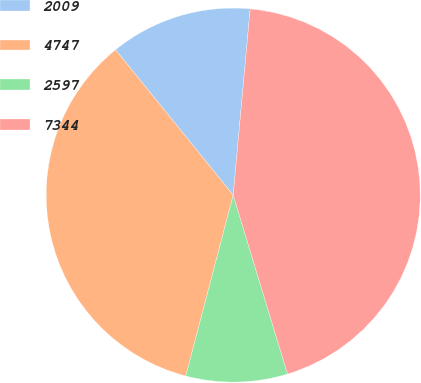Convert chart to OTSL. <chart><loc_0><loc_0><loc_500><loc_500><pie_chart><fcel>2009<fcel>4747<fcel>2597<fcel>7344<nl><fcel>12.28%<fcel>35.09%<fcel>8.77%<fcel>43.86%<nl></chart> 